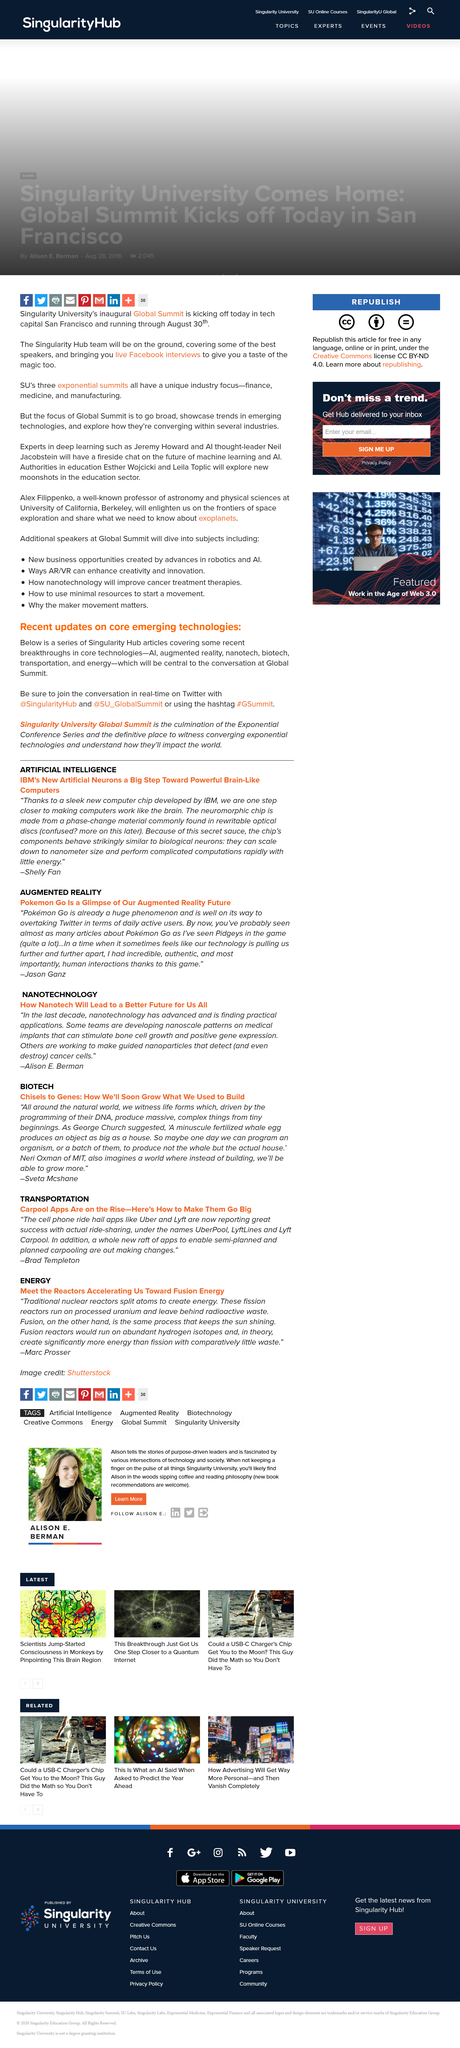Identify some key points in this picture. The hashtag to use on Twitter is #GSummit. The Exponential Conference Series is the culmination of a series of conferences that focus on innovation, technology, and entrepreneurship. Its twitter handle is @SU\_GlobalSummit. The central topic of discussion at the Global Summit will be core technologies, which are essential to the advancement of society. 